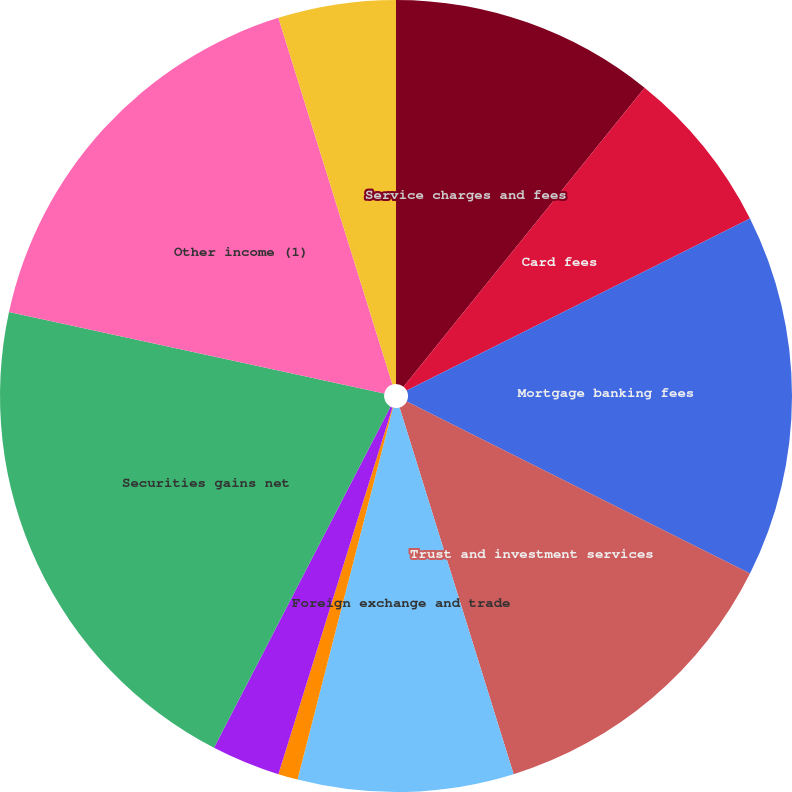<chart> <loc_0><loc_0><loc_500><loc_500><pie_chart><fcel>Service charges and fees<fcel>Card fees<fcel>Mortgage banking fees<fcel>Trust and investment services<fcel>Foreign exchange and trade<fcel>Capital markets fees<fcel>Bank-owned life insurance<fcel>Securities gains net<fcel>Other income (1)<fcel>Noninterest income<nl><fcel>10.8%<fcel>6.8%<fcel>14.8%<fcel>12.8%<fcel>8.8%<fcel>0.8%<fcel>2.8%<fcel>20.8%<fcel>16.8%<fcel>4.8%<nl></chart> 